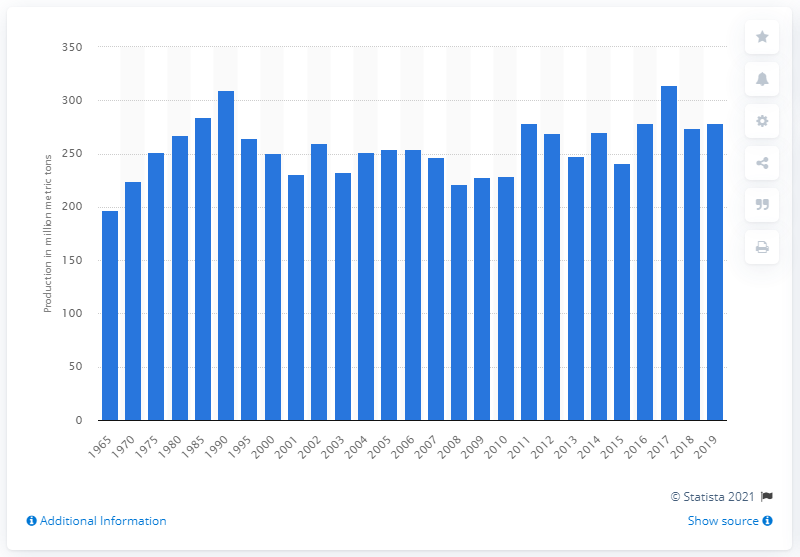Can you analyze the trends in sugar beet production from this chart? The chart depicts sugar beet production from 1965 to 2019. Overall, there has been a general upward trend in production, with some notable peaks and troughs. The early 1990s and the late 2010s show the highest production levels. It's interesting to note that despite some years of decline, the production has remained relatively stable over the last two decades, indicating a strong global demand for sugar beet. 